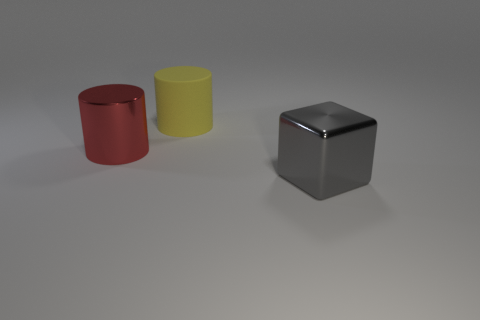What materials do the objects appear to be made of? The objects in the image seem to be made of a reflective material, likely metal due to the sheen and reflections on their surfaces.  Can you describe the lighting in this scene? The lighting appears soft and diffused, with subtle shadows indicating an overhead light source, giving the scene a calm and neutral ambiance. 